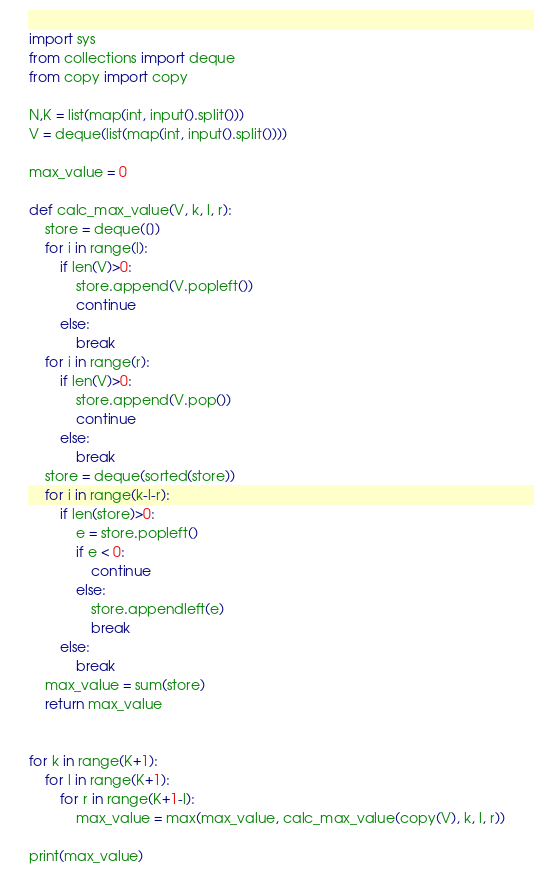<code> <loc_0><loc_0><loc_500><loc_500><_Python_>import sys
from collections import deque
from copy import copy

N,K = list(map(int, input().split()))
V = deque(list(map(int, input().split())))

max_value = 0

def calc_max_value(V, k, l, r):
    store = deque([])
    for i in range(l):
        if len(V)>0:
            store.append(V.popleft())
            continue
        else:
            break
    for i in range(r):
        if len(V)>0:
            store.append(V.pop())
            continue
        else:
            break
    store = deque(sorted(store))
    for i in range(k-l-r):
        if len(store)>0:
            e = store.popleft()
            if e < 0:
                continue
            else:
                store.appendleft(e)
                break
        else:
            break
    max_value = sum(store)
    return max_value

    
for k in range(K+1):
    for l in range(K+1):
        for r in range(K+1-l):
            max_value = max(max_value, calc_max_value(copy(V), k, l, r))

print(max_value)
</code> 